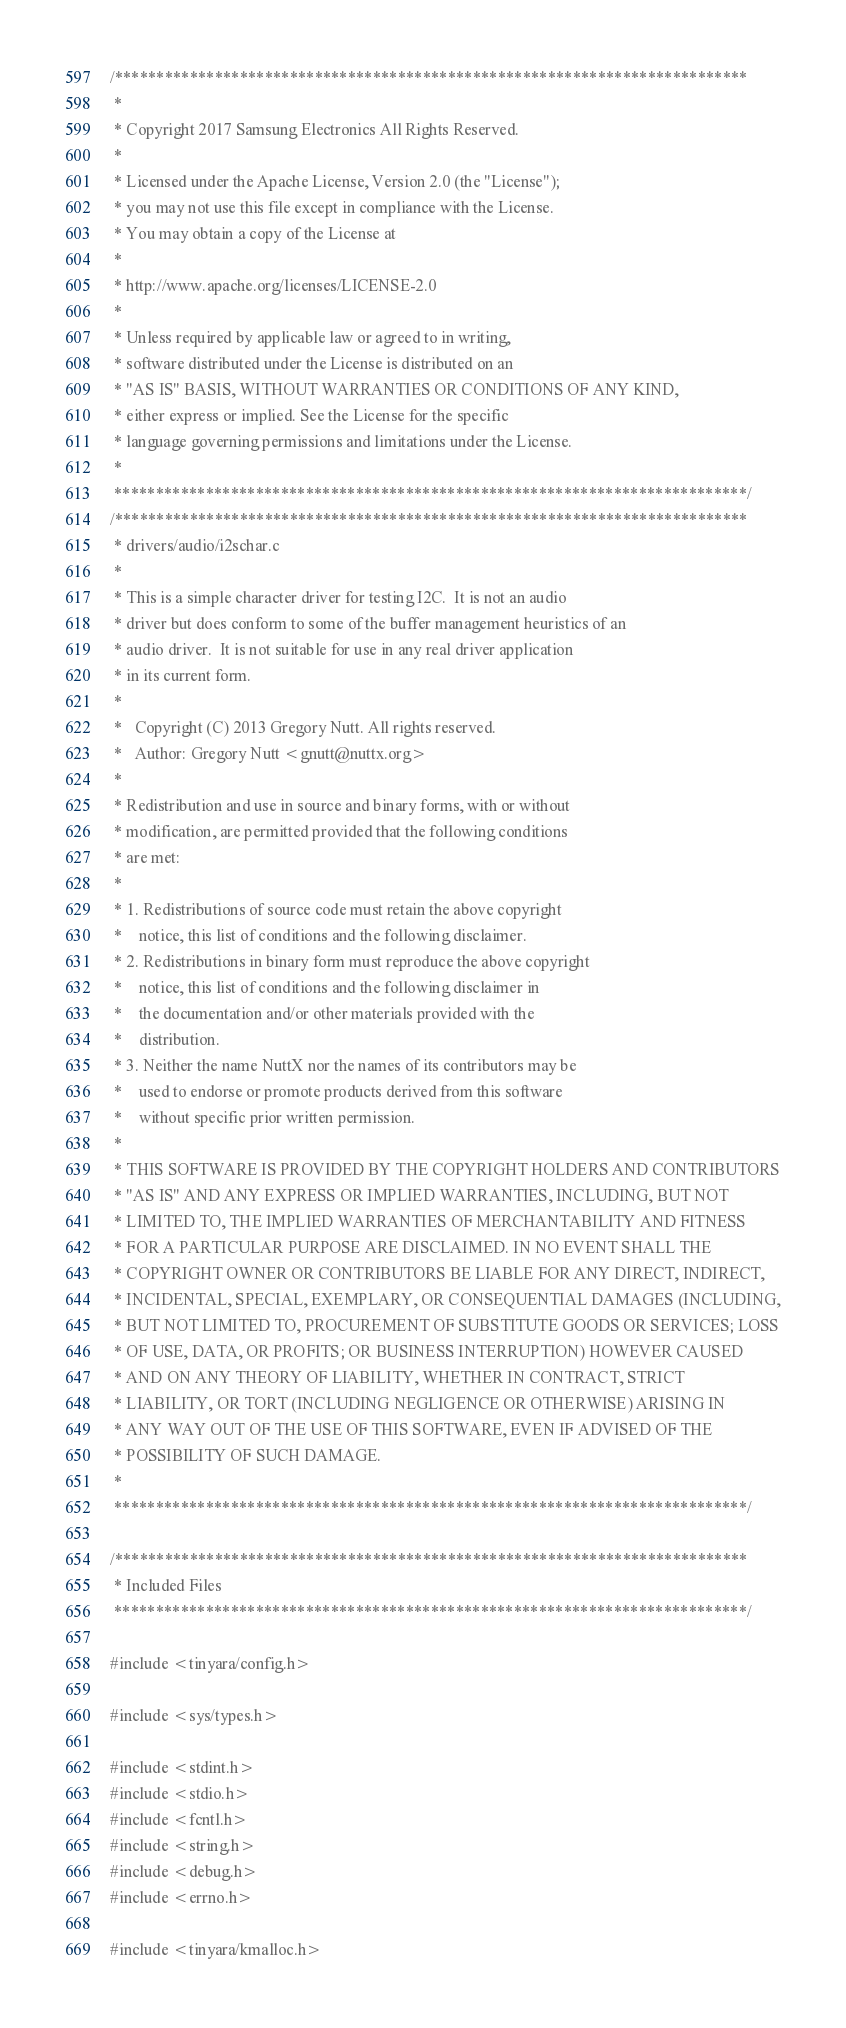<code> <loc_0><loc_0><loc_500><loc_500><_C_>/****************************************************************************
 *
 * Copyright 2017 Samsung Electronics All Rights Reserved.
 *
 * Licensed under the Apache License, Version 2.0 (the "License");
 * you may not use this file except in compliance with the License.
 * You may obtain a copy of the License at
 *
 * http://www.apache.org/licenses/LICENSE-2.0
 *
 * Unless required by applicable law or agreed to in writing,
 * software distributed under the License is distributed on an
 * "AS IS" BASIS, WITHOUT WARRANTIES OR CONDITIONS OF ANY KIND,
 * either express or implied. See the License for the specific
 * language governing permissions and limitations under the License.
 *
 ****************************************************************************/
/****************************************************************************
 * drivers/audio/i2schar.c
 *
 * This is a simple character driver for testing I2C.  It is not an audio
 * driver but does conform to some of the buffer management heuristics of an
 * audio driver.  It is not suitable for use in any real driver application
 * in its current form.
 *
 *   Copyright (C) 2013 Gregory Nutt. All rights reserved.
 *   Author: Gregory Nutt <gnutt@nuttx.org>
 *
 * Redistribution and use in source and binary forms, with or without
 * modification, are permitted provided that the following conditions
 * are met:
 *
 * 1. Redistributions of source code must retain the above copyright
 *    notice, this list of conditions and the following disclaimer.
 * 2. Redistributions in binary form must reproduce the above copyright
 *    notice, this list of conditions and the following disclaimer in
 *    the documentation and/or other materials provided with the
 *    distribution.
 * 3. Neither the name NuttX nor the names of its contributors may be
 *    used to endorse or promote products derived from this software
 *    without specific prior written permission.
 *
 * THIS SOFTWARE IS PROVIDED BY THE COPYRIGHT HOLDERS AND CONTRIBUTORS
 * "AS IS" AND ANY EXPRESS OR IMPLIED WARRANTIES, INCLUDING, BUT NOT
 * LIMITED TO, THE IMPLIED WARRANTIES OF MERCHANTABILITY AND FITNESS
 * FOR A PARTICULAR PURPOSE ARE DISCLAIMED. IN NO EVENT SHALL THE
 * COPYRIGHT OWNER OR CONTRIBUTORS BE LIABLE FOR ANY DIRECT, INDIRECT,
 * INCIDENTAL, SPECIAL, EXEMPLARY, OR CONSEQUENTIAL DAMAGES (INCLUDING,
 * BUT NOT LIMITED TO, PROCUREMENT OF SUBSTITUTE GOODS OR SERVICES; LOSS
 * OF USE, DATA, OR PROFITS; OR BUSINESS INTERRUPTION) HOWEVER CAUSED
 * AND ON ANY THEORY OF LIABILITY, WHETHER IN CONTRACT, STRICT
 * LIABILITY, OR TORT (INCLUDING NEGLIGENCE OR OTHERWISE) ARISING IN
 * ANY WAY OUT OF THE USE OF THIS SOFTWARE, EVEN IF ADVISED OF THE
 * POSSIBILITY OF SUCH DAMAGE.
 *
 ****************************************************************************/

/****************************************************************************
 * Included Files
 ****************************************************************************/

#include <tinyara/config.h>

#include <sys/types.h>

#include <stdint.h>
#include <stdio.h>
#include <fcntl.h>
#include <string.h>
#include <debug.h>
#include <errno.h>

#include <tinyara/kmalloc.h></code> 